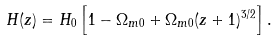Convert formula to latex. <formula><loc_0><loc_0><loc_500><loc_500>H ( z ) = H _ { 0 } \left [ 1 - \Omega _ { m 0 } + \Omega _ { m 0 } ( z + 1 ) ^ { 3 / 2 } \right ] .</formula> 